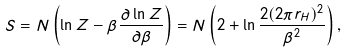<formula> <loc_0><loc_0><loc_500><loc_500>S = N \left ( { \ln Z - \beta \frac { \partial \ln Z } { \partial \beta } } \right ) = N \left ( { 2 + \ln \frac { 2 ( 2 \pi r _ { H } ) ^ { 2 } } { \beta ^ { 2 } } } \right ) ,</formula> 